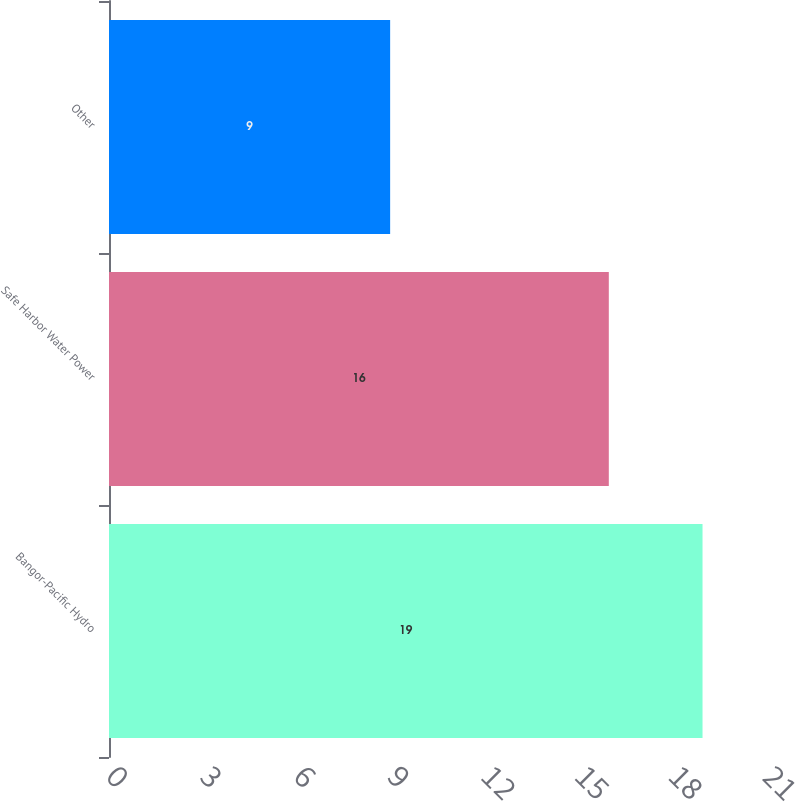Convert chart to OTSL. <chart><loc_0><loc_0><loc_500><loc_500><bar_chart><fcel>Bangor-Pacific Hydro<fcel>Safe Harbor Water Power<fcel>Other<nl><fcel>19<fcel>16<fcel>9<nl></chart> 